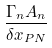<formula> <loc_0><loc_0><loc_500><loc_500>\frac { \Gamma _ { n } A _ { n } } { { \delta x } _ { P N } }</formula> 